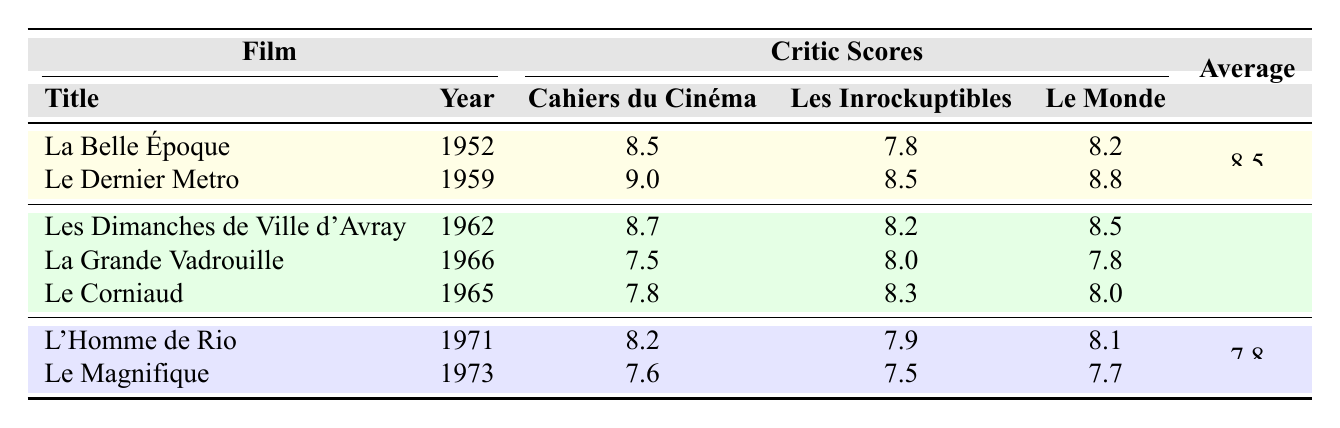What is the critic score for "La Belle Époque" in Cahiers du Cinéma? From the table, the critic score for "La Belle Époque" in Cahiers du Cinéma is listed as 8.5.
Answer: 8.5 Which film received the highest score from Les Inrockuptibles? By examining the scores from Les Inrockuptibles, "Le Dernier Metro" has the highest score of 8.5.
Answer: Le Dernier Metro What is the average critic score for the films in the 1960s? The table shows the average score for films in the 1960s is 8.1, calculated from the films listed in that decade.
Answer: 8.1 Did "L'Homme de Rio" receive a higher score in Le Monde than "Le Magnifique"? The score for "L'Homme de Rio" in Le Monde is 8.1, while "Le Magnifique" received a score of 7.7. Therefore, it did receive a higher score.
Answer: Yes Which decade had the lowest average critic score? The averages for the decades show that the 1970s had the lowest average score of 7.8, compared to 8.5 in the 1950s and 8.1 in the 1960s.
Answer: 1970s What is the score difference in Cahiers du Cinéma between "Le Dernier Metro" and "Le Corniaud"? "Le Dernier Metro" scored 9.0 and "Le Corniaud" scored 7.8 in Cahiers du Cinéma. The difference is 9.0 - 7.8 = 1.2.
Answer: 1.2 How many films from the 1950s had a critic score above 8.0 in Le Monde? In the 1950s, both "La Belle Époque" (8.2) and "Le Dernier Metro" (8.8) had scores above 8.0 in Le Monde, making a total of 2 films.
Answer: 2 Was the average score for the films from the 1970s above 8.0? The average score for the 1970s is listed as 7.8, which is below 8.0.
Answer: No Which film had the lowest score in Cahiers du Cinéma among those listed? "Le Magnifique" had the lowest score in Cahiers du Cinéma, with a score of 7.6, compared to other films listed.
Answer: Le Magnifique What is the total number of films evaluated across all decades in the table? The table lists a total of 6 films when counting the films from the 1950s (2), 1960s (3), and 1970s (2), thus totaling 7 films.
Answer: 7 